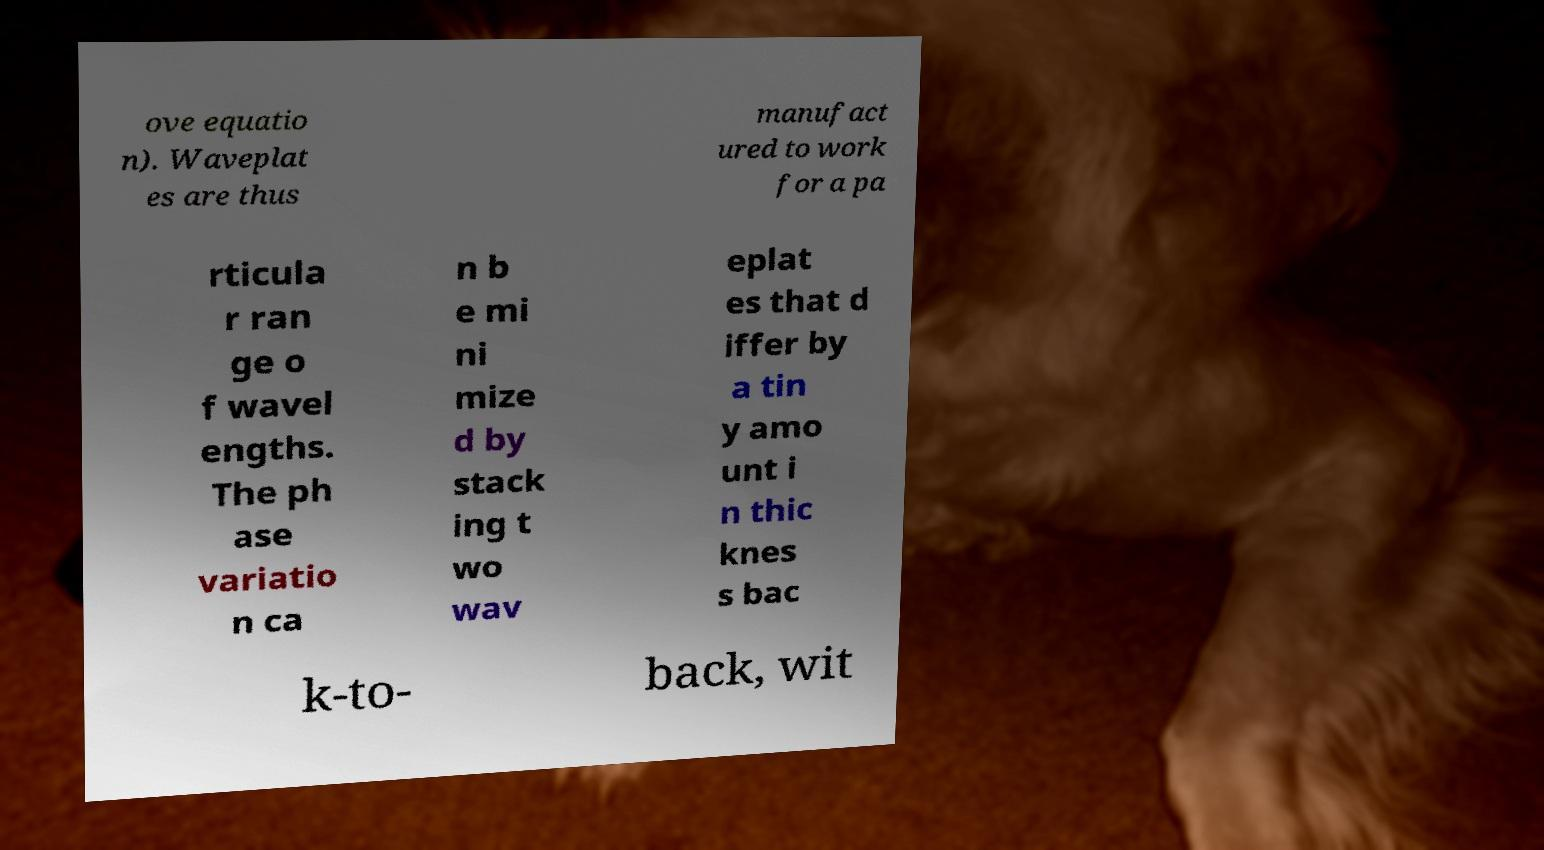There's text embedded in this image that I need extracted. Can you transcribe it verbatim? ove equatio n). Waveplat es are thus manufact ured to work for a pa rticula r ran ge o f wavel engths. The ph ase variatio n ca n b e mi ni mize d by stack ing t wo wav eplat es that d iffer by a tin y amo unt i n thic knes s bac k-to- back, wit 